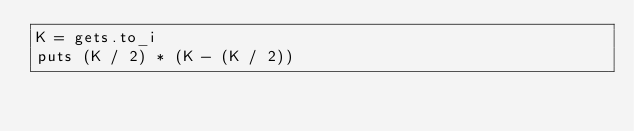Convert code to text. <code><loc_0><loc_0><loc_500><loc_500><_Ruby_>K = gets.to_i
puts (K / 2) * (K - (K / 2))</code> 